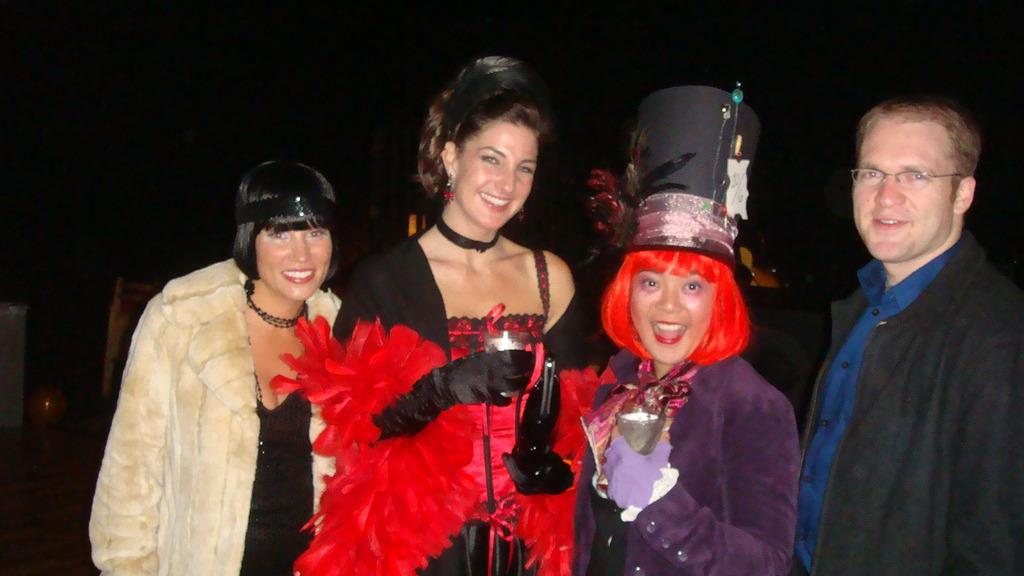How many people are in the image? There are four people in the image. What are the people doing in the image? The people are standing and smiling. What are the people in the center holding? The people in the center are holding glasses. What is the texture of the tin in the image? There is no tin present in the image. How does the expansion of the image affect the people's expressions? The image is not expanding, and the people's expressions remain the same. 